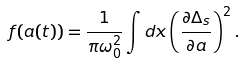Convert formula to latex. <formula><loc_0><loc_0><loc_500><loc_500>f ( a ( t ) ) = \frac { 1 } { \pi \omega _ { 0 } ^ { 2 } } \int d x \left ( \frac { \partial \Delta _ { s } } { \partial a } \right ) ^ { 2 } .</formula> 